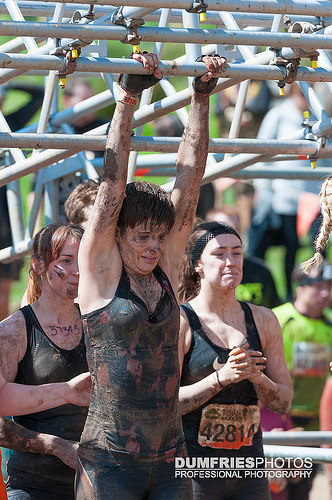<image>
Can you confirm if the shirt is on the girl? No. The shirt is not positioned on the girl. They may be near each other, but the shirt is not supported by or resting on top of the girl. Is the shirt on the person? No. The shirt is not positioned on the person. They may be near each other, but the shirt is not supported by or resting on top of the person. 